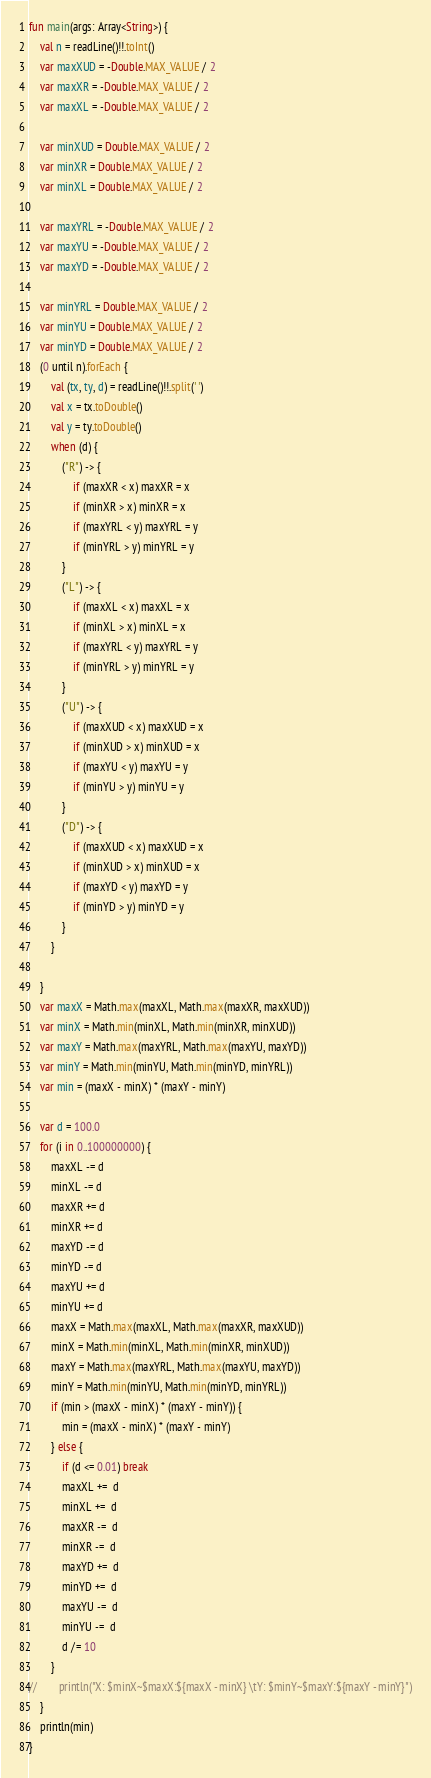Convert code to text. <code><loc_0><loc_0><loc_500><loc_500><_Kotlin_>fun main(args: Array<String>) {
    val n = readLine()!!.toInt()
    var maxXUD = -Double.MAX_VALUE / 2
    var maxXR = -Double.MAX_VALUE / 2
    var maxXL = -Double.MAX_VALUE / 2

    var minXUD = Double.MAX_VALUE / 2
    var minXR = Double.MAX_VALUE / 2
    var minXL = Double.MAX_VALUE / 2

    var maxYRL = -Double.MAX_VALUE / 2
    var maxYU = -Double.MAX_VALUE / 2
    var maxYD = -Double.MAX_VALUE / 2

    var minYRL = Double.MAX_VALUE / 2
    var minYU = Double.MAX_VALUE / 2
    var minYD = Double.MAX_VALUE / 2
    (0 until n).forEach {
        val (tx, ty, d) = readLine()!!.split(' ')
        val x = tx.toDouble()
        val y = ty.toDouble()
        when (d) {
            ("R") -> {
                if (maxXR < x) maxXR = x
                if (minXR > x) minXR = x
                if (maxYRL < y) maxYRL = y
                if (minYRL > y) minYRL = y
            }
            ("L") -> {
                if (maxXL < x) maxXL = x
                if (minXL > x) minXL = x
                if (maxYRL < y) maxYRL = y
                if (minYRL > y) minYRL = y
            }
            ("U") -> {
                if (maxXUD < x) maxXUD = x
                if (minXUD > x) minXUD = x
                if (maxYU < y) maxYU = y
                if (minYU > y) minYU = y
            }
            ("D") -> {
                if (maxXUD < x) maxXUD = x
                if (minXUD > x) minXUD = x
                if (maxYD < y) maxYD = y
                if (minYD > y) minYD = y
            }
        }

    }
    var maxX = Math.max(maxXL, Math.max(maxXR, maxXUD))
    var minX = Math.min(minXL, Math.min(minXR, minXUD))
    var maxY = Math.max(maxYRL, Math.max(maxYU, maxYD))
    var minY = Math.min(minYU, Math.min(minYD, minYRL))
    var min = (maxX - minX) * (maxY - minY)

    var d = 100.0
    for (i in 0..100000000) {
        maxXL -= d
        minXL -= d
        maxXR += d
        minXR += d
        maxYD -= d
        minYD -= d
        maxYU += d
        minYU += d
        maxX = Math.max(maxXL, Math.max(maxXR, maxXUD))
        minX = Math.min(minXL, Math.min(minXR, minXUD))
        maxY = Math.max(maxYRL, Math.max(maxYU, maxYD))
        minY = Math.min(minYU, Math.min(minYD, minYRL))
        if (min > (maxX - minX) * (maxY - minY)) {
            min = (maxX - minX) * (maxY - minY)
        } else {
            if (d <= 0.01) break
            maxXL +=  d
            minXL +=  d
            maxXR -=  d
            minXR -=  d
            maxYD +=  d
            minYD +=  d
            maxYU -=  d
            minYU -=  d
            d /= 10
        }
//        println("X: $minX~$maxX:${maxX - minX} \tY: $minY~$maxY:${maxY - minY}")
    }
    println(min)
}</code> 